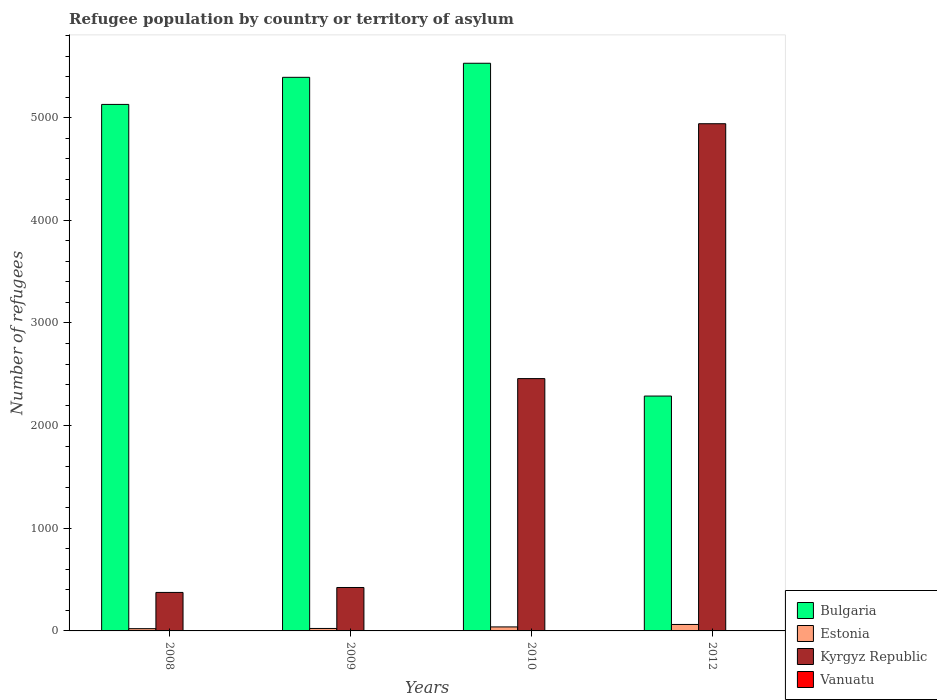How many different coloured bars are there?
Offer a very short reply. 4. How many groups of bars are there?
Your answer should be compact. 4. Are the number of bars on each tick of the X-axis equal?
Give a very brief answer. Yes. How many bars are there on the 4th tick from the left?
Keep it short and to the point. 4. How many bars are there on the 2nd tick from the right?
Offer a terse response. 4. What is the label of the 4th group of bars from the left?
Give a very brief answer. 2012. In how many cases, is the number of bars for a given year not equal to the number of legend labels?
Your response must be concise. 0. What is the number of refugees in Kyrgyz Republic in 2012?
Give a very brief answer. 4941. Across all years, what is the maximum number of refugees in Bulgaria?
Offer a very short reply. 5530. Across all years, what is the minimum number of refugees in Vanuatu?
Your response must be concise. 2. In which year was the number of refugees in Vanuatu minimum?
Make the answer very short. 2012. What is the total number of refugees in Estonia in the graph?
Make the answer very short. 148. What is the difference between the number of refugees in Kyrgyz Republic in 2008 and that in 2009?
Keep it short and to the point. -48. What is the difference between the number of refugees in Estonia in 2010 and the number of refugees in Vanuatu in 2009?
Your answer should be very brief. 35. What is the average number of refugees in Vanuatu per year?
Offer a terse response. 3.25. In the year 2009, what is the difference between the number of refugees in Kyrgyz Republic and number of refugees in Bulgaria?
Provide a short and direct response. -4970. What is the ratio of the number of refugees in Kyrgyz Republic in 2010 to that in 2012?
Offer a terse response. 0.5. Is the number of refugees in Vanuatu in 2009 less than that in 2010?
Provide a succinct answer. No. Is the difference between the number of refugees in Kyrgyz Republic in 2009 and 2010 greater than the difference between the number of refugees in Bulgaria in 2009 and 2010?
Your answer should be very brief. No. What is the difference between the highest and the second highest number of refugees in Vanuatu?
Provide a succinct answer. 0. What is the difference between the highest and the lowest number of refugees in Bulgaria?
Offer a very short reply. 3242. In how many years, is the number of refugees in Vanuatu greater than the average number of refugees in Vanuatu taken over all years?
Your response must be concise. 2. What does the 2nd bar from the left in 2012 represents?
Give a very brief answer. Estonia. How many bars are there?
Your answer should be very brief. 16. Are all the bars in the graph horizontal?
Your answer should be very brief. No. What is the difference between two consecutive major ticks on the Y-axis?
Provide a short and direct response. 1000. Are the values on the major ticks of Y-axis written in scientific E-notation?
Ensure brevity in your answer.  No. Does the graph contain any zero values?
Provide a short and direct response. No. Does the graph contain grids?
Offer a terse response. No. How many legend labels are there?
Offer a very short reply. 4. How are the legend labels stacked?
Keep it short and to the point. Vertical. What is the title of the graph?
Your answer should be very brief. Refugee population by country or territory of asylum. Does "Kuwait" appear as one of the legend labels in the graph?
Keep it short and to the point. No. What is the label or title of the X-axis?
Make the answer very short. Years. What is the label or title of the Y-axis?
Keep it short and to the point. Number of refugees. What is the Number of refugees of Bulgaria in 2008?
Provide a short and direct response. 5129. What is the Number of refugees of Kyrgyz Republic in 2008?
Keep it short and to the point. 375. What is the Number of refugees in Vanuatu in 2008?
Your answer should be compact. 3. What is the Number of refugees in Bulgaria in 2009?
Ensure brevity in your answer.  5393. What is the Number of refugees of Kyrgyz Republic in 2009?
Provide a short and direct response. 423. What is the Number of refugees of Bulgaria in 2010?
Ensure brevity in your answer.  5530. What is the Number of refugees of Kyrgyz Republic in 2010?
Your response must be concise. 2458. What is the Number of refugees of Vanuatu in 2010?
Give a very brief answer. 4. What is the Number of refugees in Bulgaria in 2012?
Offer a terse response. 2288. What is the Number of refugees of Estonia in 2012?
Ensure brevity in your answer.  63. What is the Number of refugees in Kyrgyz Republic in 2012?
Keep it short and to the point. 4941. What is the Number of refugees in Vanuatu in 2012?
Your response must be concise. 2. Across all years, what is the maximum Number of refugees in Bulgaria?
Make the answer very short. 5530. Across all years, what is the maximum Number of refugees in Kyrgyz Republic?
Give a very brief answer. 4941. Across all years, what is the minimum Number of refugees in Bulgaria?
Offer a terse response. 2288. Across all years, what is the minimum Number of refugees of Estonia?
Your answer should be compact. 22. Across all years, what is the minimum Number of refugees of Kyrgyz Republic?
Give a very brief answer. 375. Across all years, what is the minimum Number of refugees of Vanuatu?
Ensure brevity in your answer.  2. What is the total Number of refugees in Bulgaria in the graph?
Keep it short and to the point. 1.83e+04. What is the total Number of refugees in Estonia in the graph?
Your response must be concise. 148. What is the total Number of refugees in Kyrgyz Republic in the graph?
Your response must be concise. 8197. What is the total Number of refugees in Vanuatu in the graph?
Give a very brief answer. 13. What is the difference between the Number of refugees of Bulgaria in 2008 and that in 2009?
Provide a short and direct response. -264. What is the difference between the Number of refugees of Kyrgyz Republic in 2008 and that in 2009?
Your answer should be compact. -48. What is the difference between the Number of refugees of Vanuatu in 2008 and that in 2009?
Your response must be concise. -1. What is the difference between the Number of refugees in Bulgaria in 2008 and that in 2010?
Provide a succinct answer. -401. What is the difference between the Number of refugees of Kyrgyz Republic in 2008 and that in 2010?
Make the answer very short. -2083. What is the difference between the Number of refugees in Bulgaria in 2008 and that in 2012?
Give a very brief answer. 2841. What is the difference between the Number of refugees in Estonia in 2008 and that in 2012?
Keep it short and to the point. -41. What is the difference between the Number of refugees in Kyrgyz Republic in 2008 and that in 2012?
Offer a terse response. -4566. What is the difference between the Number of refugees in Vanuatu in 2008 and that in 2012?
Keep it short and to the point. 1. What is the difference between the Number of refugees in Bulgaria in 2009 and that in 2010?
Your answer should be very brief. -137. What is the difference between the Number of refugees of Kyrgyz Republic in 2009 and that in 2010?
Offer a terse response. -2035. What is the difference between the Number of refugees of Bulgaria in 2009 and that in 2012?
Provide a succinct answer. 3105. What is the difference between the Number of refugees of Estonia in 2009 and that in 2012?
Your answer should be compact. -39. What is the difference between the Number of refugees of Kyrgyz Republic in 2009 and that in 2012?
Make the answer very short. -4518. What is the difference between the Number of refugees in Vanuatu in 2009 and that in 2012?
Offer a terse response. 2. What is the difference between the Number of refugees of Bulgaria in 2010 and that in 2012?
Keep it short and to the point. 3242. What is the difference between the Number of refugees in Kyrgyz Republic in 2010 and that in 2012?
Ensure brevity in your answer.  -2483. What is the difference between the Number of refugees in Vanuatu in 2010 and that in 2012?
Make the answer very short. 2. What is the difference between the Number of refugees of Bulgaria in 2008 and the Number of refugees of Estonia in 2009?
Ensure brevity in your answer.  5105. What is the difference between the Number of refugees of Bulgaria in 2008 and the Number of refugees of Kyrgyz Republic in 2009?
Ensure brevity in your answer.  4706. What is the difference between the Number of refugees in Bulgaria in 2008 and the Number of refugees in Vanuatu in 2009?
Ensure brevity in your answer.  5125. What is the difference between the Number of refugees in Estonia in 2008 and the Number of refugees in Kyrgyz Republic in 2009?
Provide a short and direct response. -401. What is the difference between the Number of refugees of Estonia in 2008 and the Number of refugees of Vanuatu in 2009?
Ensure brevity in your answer.  18. What is the difference between the Number of refugees of Kyrgyz Republic in 2008 and the Number of refugees of Vanuatu in 2009?
Give a very brief answer. 371. What is the difference between the Number of refugees in Bulgaria in 2008 and the Number of refugees in Estonia in 2010?
Provide a succinct answer. 5090. What is the difference between the Number of refugees of Bulgaria in 2008 and the Number of refugees of Kyrgyz Republic in 2010?
Keep it short and to the point. 2671. What is the difference between the Number of refugees in Bulgaria in 2008 and the Number of refugees in Vanuatu in 2010?
Ensure brevity in your answer.  5125. What is the difference between the Number of refugees of Estonia in 2008 and the Number of refugees of Kyrgyz Republic in 2010?
Provide a succinct answer. -2436. What is the difference between the Number of refugees of Estonia in 2008 and the Number of refugees of Vanuatu in 2010?
Make the answer very short. 18. What is the difference between the Number of refugees in Kyrgyz Republic in 2008 and the Number of refugees in Vanuatu in 2010?
Ensure brevity in your answer.  371. What is the difference between the Number of refugees of Bulgaria in 2008 and the Number of refugees of Estonia in 2012?
Ensure brevity in your answer.  5066. What is the difference between the Number of refugees in Bulgaria in 2008 and the Number of refugees in Kyrgyz Republic in 2012?
Your answer should be compact. 188. What is the difference between the Number of refugees in Bulgaria in 2008 and the Number of refugees in Vanuatu in 2012?
Your response must be concise. 5127. What is the difference between the Number of refugees of Estonia in 2008 and the Number of refugees of Kyrgyz Republic in 2012?
Your answer should be compact. -4919. What is the difference between the Number of refugees in Kyrgyz Republic in 2008 and the Number of refugees in Vanuatu in 2012?
Ensure brevity in your answer.  373. What is the difference between the Number of refugees of Bulgaria in 2009 and the Number of refugees of Estonia in 2010?
Your response must be concise. 5354. What is the difference between the Number of refugees in Bulgaria in 2009 and the Number of refugees in Kyrgyz Republic in 2010?
Your response must be concise. 2935. What is the difference between the Number of refugees of Bulgaria in 2009 and the Number of refugees of Vanuatu in 2010?
Give a very brief answer. 5389. What is the difference between the Number of refugees in Estonia in 2009 and the Number of refugees in Kyrgyz Republic in 2010?
Your answer should be very brief. -2434. What is the difference between the Number of refugees of Kyrgyz Republic in 2009 and the Number of refugees of Vanuatu in 2010?
Your response must be concise. 419. What is the difference between the Number of refugees of Bulgaria in 2009 and the Number of refugees of Estonia in 2012?
Provide a short and direct response. 5330. What is the difference between the Number of refugees in Bulgaria in 2009 and the Number of refugees in Kyrgyz Republic in 2012?
Your answer should be very brief. 452. What is the difference between the Number of refugees of Bulgaria in 2009 and the Number of refugees of Vanuatu in 2012?
Provide a short and direct response. 5391. What is the difference between the Number of refugees in Estonia in 2009 and the Number of refugees in Kyrgyz Republic in 2012?
Provide a short and direct response. -4917. What is the difference between the Number of refugees in Kyrgyz Republic in 2009 and the Number of refugees in Vanuatu in 2012?
Keep it short and to the point. 421. What is the difference between the Number of refugees of Bulgaria in 2010 and the Number of refugees of Estonia in 2012?
Ensure brevity in your answer.  5467. What is the difference between the Number of refugees in Bulgaria in 2010 and the Number of refugees in Kyrgyz Republic in 2012?
Your response must be concise. 589. What is the difference between the Number of refugees in Bulgaria in 2010 and the Number of refugees in Vanuatu in 2012?
Keep it short and to the point. 5528. What is the difference between the Number of refugees in Estonia in 2010 and the Number of refugees in Kyrgyz Republic in 2012?
Keep it short and to the point. -4902. What is the difference between the Number of refugees in Kyrgyz Republic in 2010 and the Number of refugees in Vanuatu in 2012?
Provide a short and direct response. 2456. What is the average Number of refugees in Bulgaria per year?
Your answer should be compact. 4585. What is the average Number of refugees in Kyrgyz Republic per year?
Give a very brief answer. 2049.25. What is the average Number of refugees of Vanuatu per year?
Provide a short and direct response. 3.25. In the year 2008, what is the difference between the Number of refugees of Bulgaria and Number of refugees of Estonia?
Make the answer very short. 5107. In the year 2008, what is the difference between the Number of refugees of Bulgaria and Number of refugees of Kyrgyz Republic?
Give a very brief answer. 4754. In the year 2008, what is the difference between the Number of refugees in Bulgaria and Number of refugees in Vanuatu?
Keep it short and to the point. 5126. In the year 2008, what is the difference between the Number of refugees in Estonia and Number of refugees in Kyrgyz Republic?
Your answer should be compact. -353. In the year 2008, what is the difference between the Number of refugees of Estonia and Number of refugees of Vanuatu?
Provide a succinct answer. 19. In the year 2008, what is the difference between the Number of refugees of Kyrgyz Republic and Number of refugees of Vanuatu?
Provide a succinct answer. 372. In the year 2009, what is the difference between the Number of refugees in Bulgaria and Number of refugees in Estonia?
Make the answer very short. 5369. In the year 2009, what is the difference between the Number of refugees in Bulgaria and Number of refugees in Kyrgyz Republic?
Give a very brief answer. 4970. In the year 2009, what is the difference between the Number of refugees of Bulgaria and Number of refugees of Vanuatu?
Your answer should be very brief. 5389. In the year 2009, what is the difference between the Number of refugees in Estonia and Number of refugees in Kyrgyz Republic?
Offer a terse response. -399. In the year 2009, what is the difference between the Number of refugees in Kyrgyz Republic and Number of refugees in Vanuatu?
Your answer should be compact. 419. In the year 2010, what is the difference between the Number of refugees of Bulgaria and Number of refugees of Estonia?
Ensure brevity in your answer.  5491. In the year 2010, what is the difference between the Number of refugees of Bulgaria and Number of refugees of Kyrgyz Republic?
Provide a succinct answer. 3072. In the year 2010, what is the difference between the Number of refugees in Bulgaria and Number of refugees in Vanuatu?
Provide a succinct answer. 5526. In the year 2010, what is the difference between the Number of refugees of Estonia and Number of refugees of Kyrgyz Republic?
Your answer should be compact. -2419. In the year 2010, what is the difference between the Number of refugees of Kyrgyz Republic and Number of refugees of Vanuatu?
Ensure brevity in your answer.  2454. In the year 2012, what is the difference between the Number of refugees in Bulgaria and Number of refugees in Estonia?
Offer a terse response. 2225. In the year 2012, what is the difference between the Number of refugees of Bulgaria and Number of refugees of Kyrgyz Republic?
Offer a very short reply. -2653. In the year 2012, what is the difference between the Number of refugees in Bulgaria and Number of refugees in Vanuatu?
Your answer should be very brief. 2286. In the year 2012, what is the difference between the Number of refugees of Estonia and Number of refugees of Kyrgyz Republic?
Make the answer very short. -4878. In the year 2012, what is the difference between the Number of refugees of Kyrgyz Republic and Number of refugees of Vanuatu?
Ensure brevity in your answer.  4939. What is the ratio of the Number of refugees in Bulgaria in 2008 to that in 2009?
Give a very brief answer. 0.95. What is the ratio of the Number of refugees in Kyrgyz Republic in 2008 to that in 2009?
Your response must be concise. 0.89. What is the ratio of the Number of refugees of Vanuatu in 2008 to that in 2009?
Provide a succinct answer. 0.75. What is the ratio of the Number of refugees in Bulgaria in 2008 to that in 2010?
Provide a succinct answer. 0.93. What is the ratio of the Number of refugees in Estonia in 2008 to that in 2010?
Keep it short and to the point. 0.56. What is the ratio of the Number of refugees of Kyrgyz Republic in 2008 to that in 2010?
Ensure brevity in your answer.  0.15. What is the ratio of the Number of refugees in Vanuatu in 2008 to that in 2010?
Your answer should be very brief. 0.75. What is the ratio of the Number of refugees of Bulgaria in 2008 to that in 2012?
Provide a succinct answer. 2.24. What is the ratio of the Number of refugees of Estonia in 2008 to that in 2012?
Provide a short and direct response. 0.35. What is the ratio of the Number of refugees of Kyrgyz Republic in 2008 to that in 2012?
Keep it short and to the point. 0.08. What is the ratio of the Number of refugees of Vanuatu in 2008 to that in 2012?
Your answer should be very brief. 1.5. What is the ratio of the Number of refugees in Bulgaria in 2009 to that in 2010?
Offer a very short reply. 0.98. What is the ratio of the Number of refugees of Estonia in 2009 to that in 2010?
Your response must be concise. 0.62. What is the ratio of the Number of refugees in Kyrgyz Republic in 2009 to that in 2010?
Your answer should be very brief. 0.17. What is the ratio of the Number of refugees in Bulgaria in 2009 to that in 2012?
Provide a succinct answer. 2.36. What is the ratio of the Number of refugees in Estonia in 2009 to that in 2012?
Your response must be concise. 0.38. What is the ratio of the Number of refugees of Kyrgyz Republic in 2009 to that in 2012?
Make the answer very short. 0.09. What is the ratio of the Number of refugees in Bulgaria in 2010 to that in 2012?
Offer a very short reply. 2.42. What is the ratio of the Number of refugees in Estonia in 2010 to that in 2012?
Provide a succinct answer. 0.62. What is the ratio of the Number of refugees of Kyrgyz Republic in 2010 to that in 2012?
Ensure brevity in your answer.  0.5. What is the ratio of the Number of refugees of Vanuatu in 2010 to that in 2012?
Make the answer very short. 2. What is the difference between the highest and the second highest Number of refugees in Bulgaria?
Provide a succinct answer. 137. What is the difference between the highest and the second highest Number of refugees of Kyrgyz Republic?
Make the answer very short. 2483. What is the difference between the highest and the lowest Number of refugees of Bulgaria?
Offer a terse response. 3242. What is the difference between the highest and the lowest Number of refugees of Estonia?
Ensure brevity in your answer.  41. What is the difference between the highest and the lowest Number of refugees of Kyrgyz Republic?
Your response must be concise. 4566. 